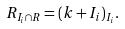<formula> <loc_0><loc_0><loc_500><loc_500>R _ { I _ { i } \cap R } = ( k + I _ { i } ) _ { I _ { i } } .</formula> 